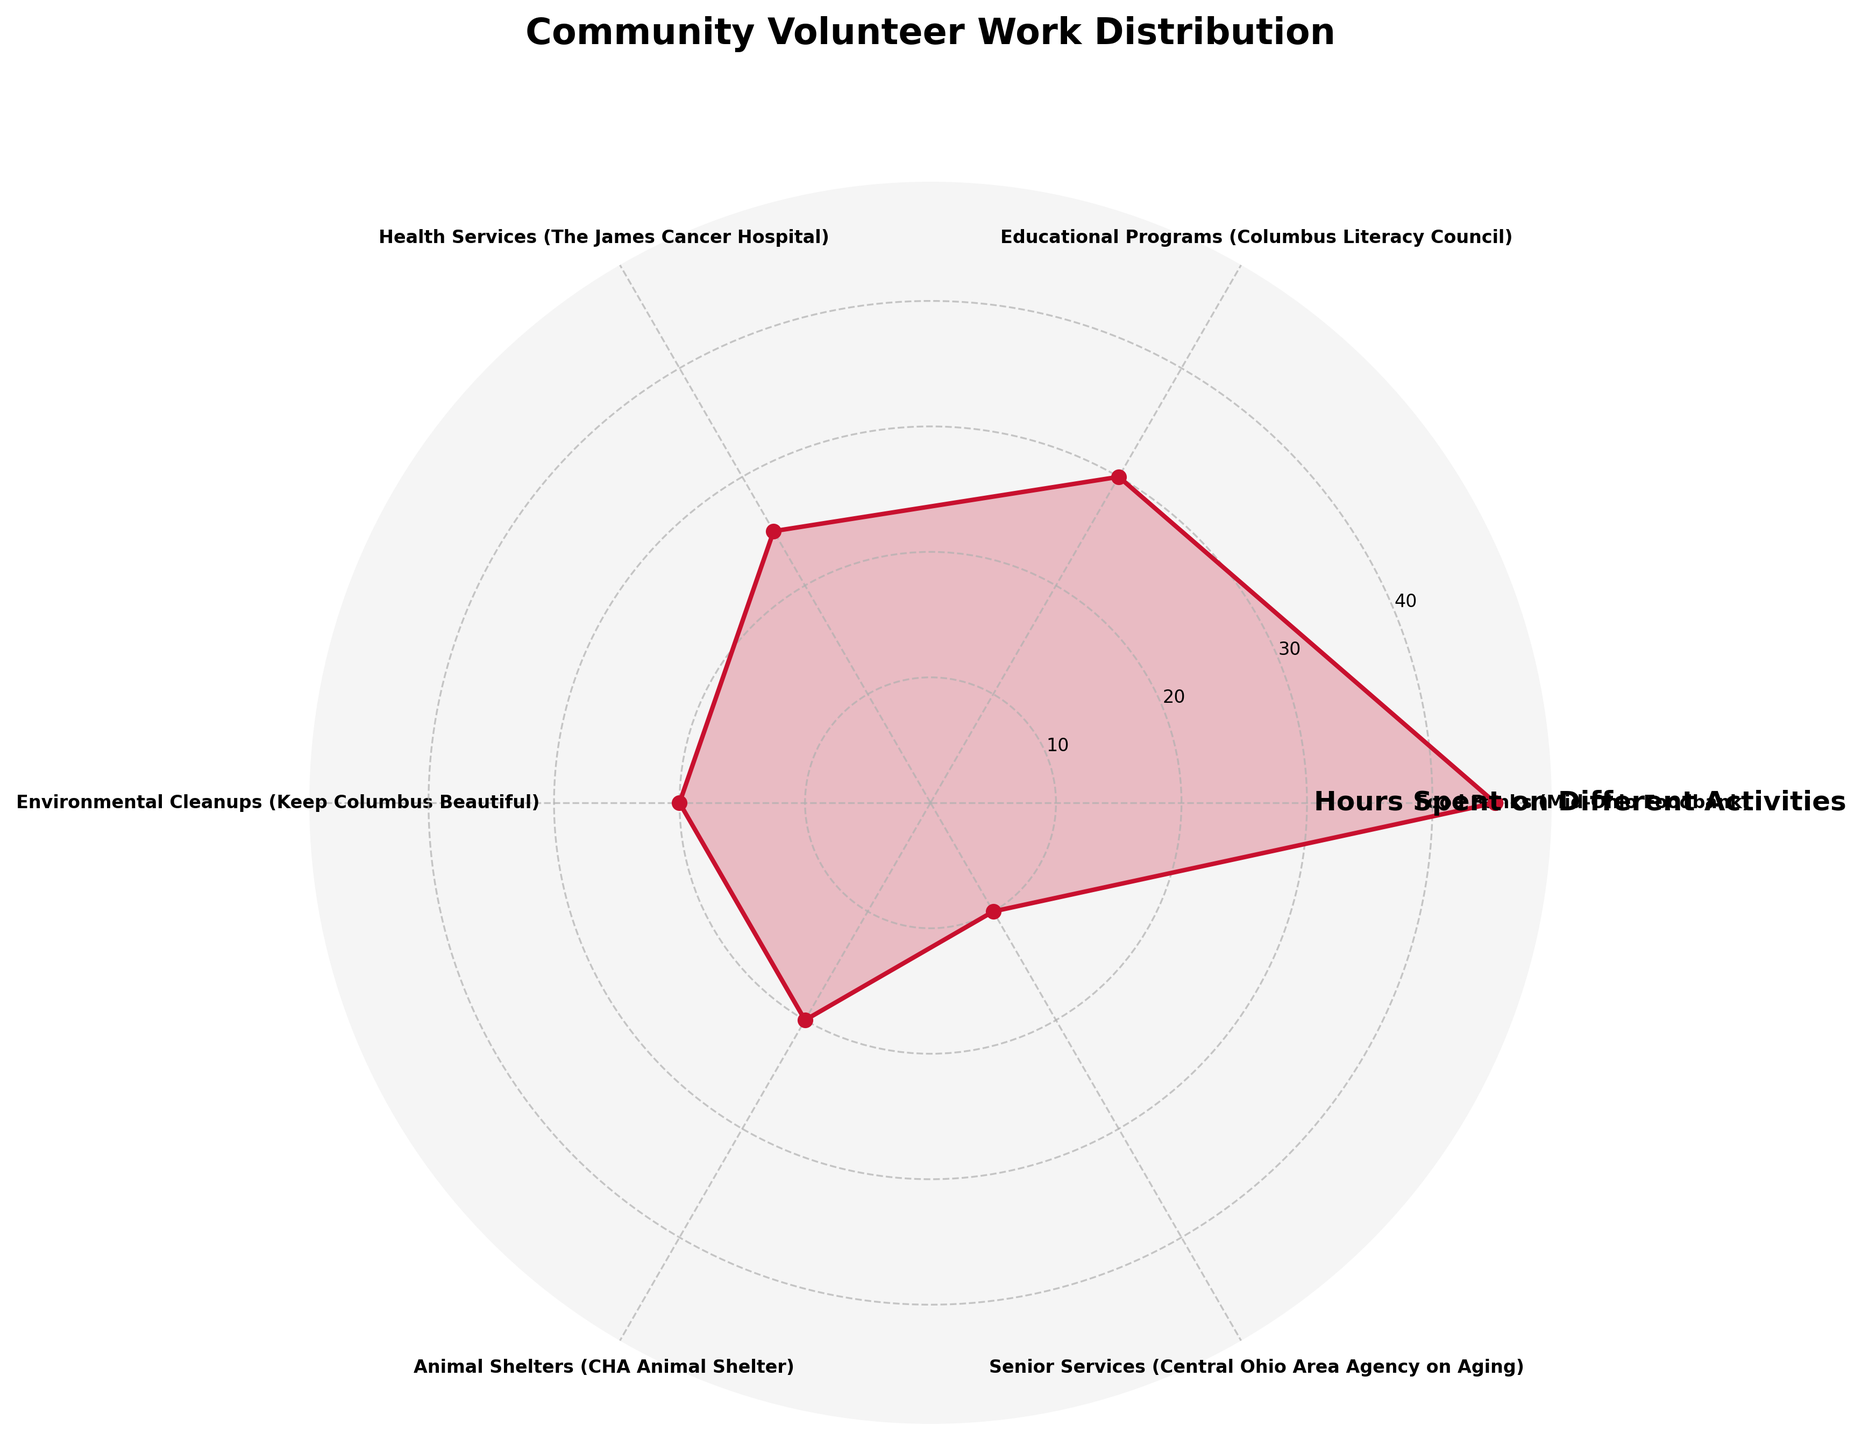What's the title of the figure? The title of the figure is usually displayed at the top and gives a quick summary of what the figure represents. In this case, the title is: "Community Volunteer Work Distribution".
Answer: Community Volunteer Work Distribution Which activity has the most volunteer hours? By examining the length and position of the segments within the polar area chart, the activity with the longest segment corresponding to the highest number of volunteer hours will be identified. The "Food Banks (Mid-Ohio Foodbank)" segment is the longest.
Answer: Food Banks (Mid-Ohio Foodbank) How many activities have volunteer hours of 20 or more? To answer this question, one needs to count the radial segments with values of 20 and above. The activities are: Food Banks (45), Educational Programs (30), Health Services (25), Environmental Cleanups (20), and Animal Shelters (20).
Answer: 5 Which activity has the fewest volunteer hours? By identifying the shortest segment in the polar chart, we determine the activity with the smallest number of volunteer hours. The shortest segment corresponds to "Senior Services (Central Ohio Area Agency on Aging)".
Answer: Senior Services (Central Ohio Area Agency on Aging) What is the total number of volunteer hours across all activities? Sum all the volunteer hours from the dataset: 45 (Food Banks) + 30 (Educational Programs) + 25 (Health Services) + 20 (Environmental Cleanups) + 20 (Animal Shelters) + 10 (Senior Services). The total is 150 hours.
Answer: 150 What is the average number of volunteer hours per activity? Calculate the average by dividing the total number of volunteer hours (150) by the number of activities (6). So, the average is 150 / 6 = 25 hours.
Answer: 25 Compare the volunteer hours between Health Services and Environmental Cleanups. Which has more hours? Look at the corresponding segments for Health Services and Environmental Cleanups. Health Services has 25 hours, whereas Environmental Cleanups have 20 hours. Therefore, Health Services has more hours.
Answer: Health Services Are there any activities with equal volunteer hours? Based on the segments in the polar chart, compare the volunteer hours attributed to each activity. Both Environmental Cleanups and Animal Shelters have 20 hours each.
Answer: Yes How much more volunteer hours does Food Banks have than Educational Programs? Subtract the volunteer hours of Educational Programs (30) from those of Food Banks (45). The difference is 45 - 30 = 15 hours.
Answer: 15 If the volunteer hours for Animal Shelters were doubled, would it surpass the hours of Food Banks? Calculate the doubled volunteer hours for Animal Shelters (20 * 2 = 40). Compare 40 to the hours of Food Banks (45). Since 40 is less than 45, it would not surpass Food Banks.
Answer: No 